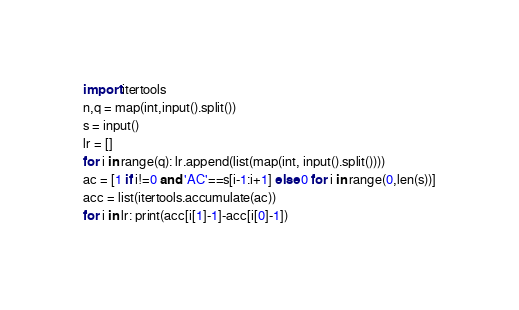Convert code to text. <code><loc_0><loc_0><loc_500><loc_500><_Python_>import itertools
n,q = map(int,input().split())
s = input()
lr = []
for i in range(q): lr.append(list(map(int, input().split())))
ac = [1 if i!=0 and 'AC'==s[i-1:i+1] else 0 for i in range(0,len(s))]
acc = list(itertools.accumulate(ac))
for i in lr: print(acc[i[1]-1]-acc[i[0]-1])
</code> 